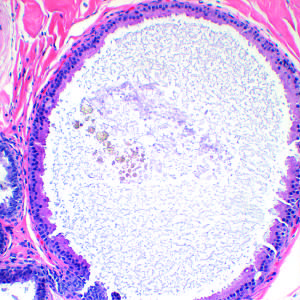what is shown that is a common feature of nonproliferative breast disease?
Answer the question using a single word or phrase. An apocrine cyst 